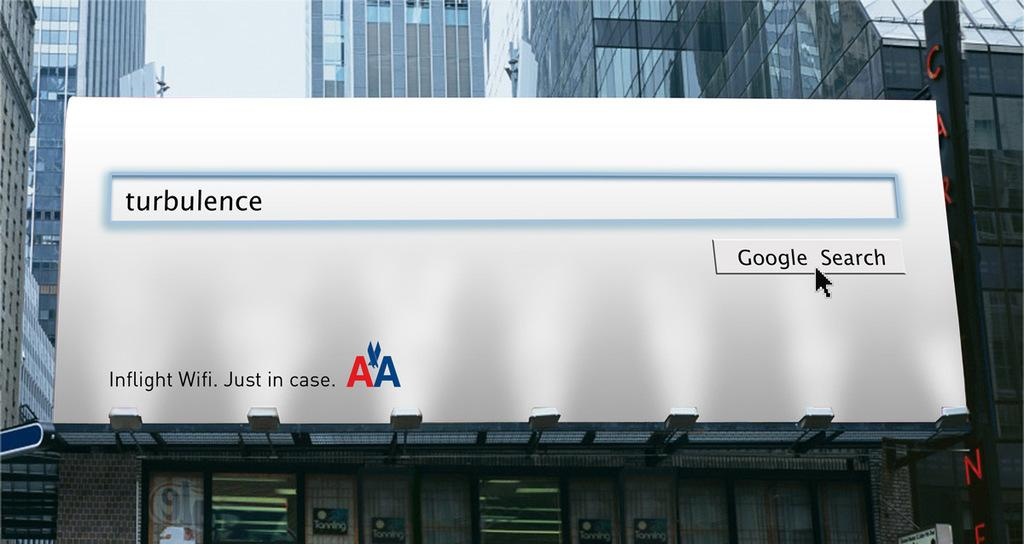<image>
Share a concise interpretation of the image provided. A billboard depicts a google search for turbulence. 